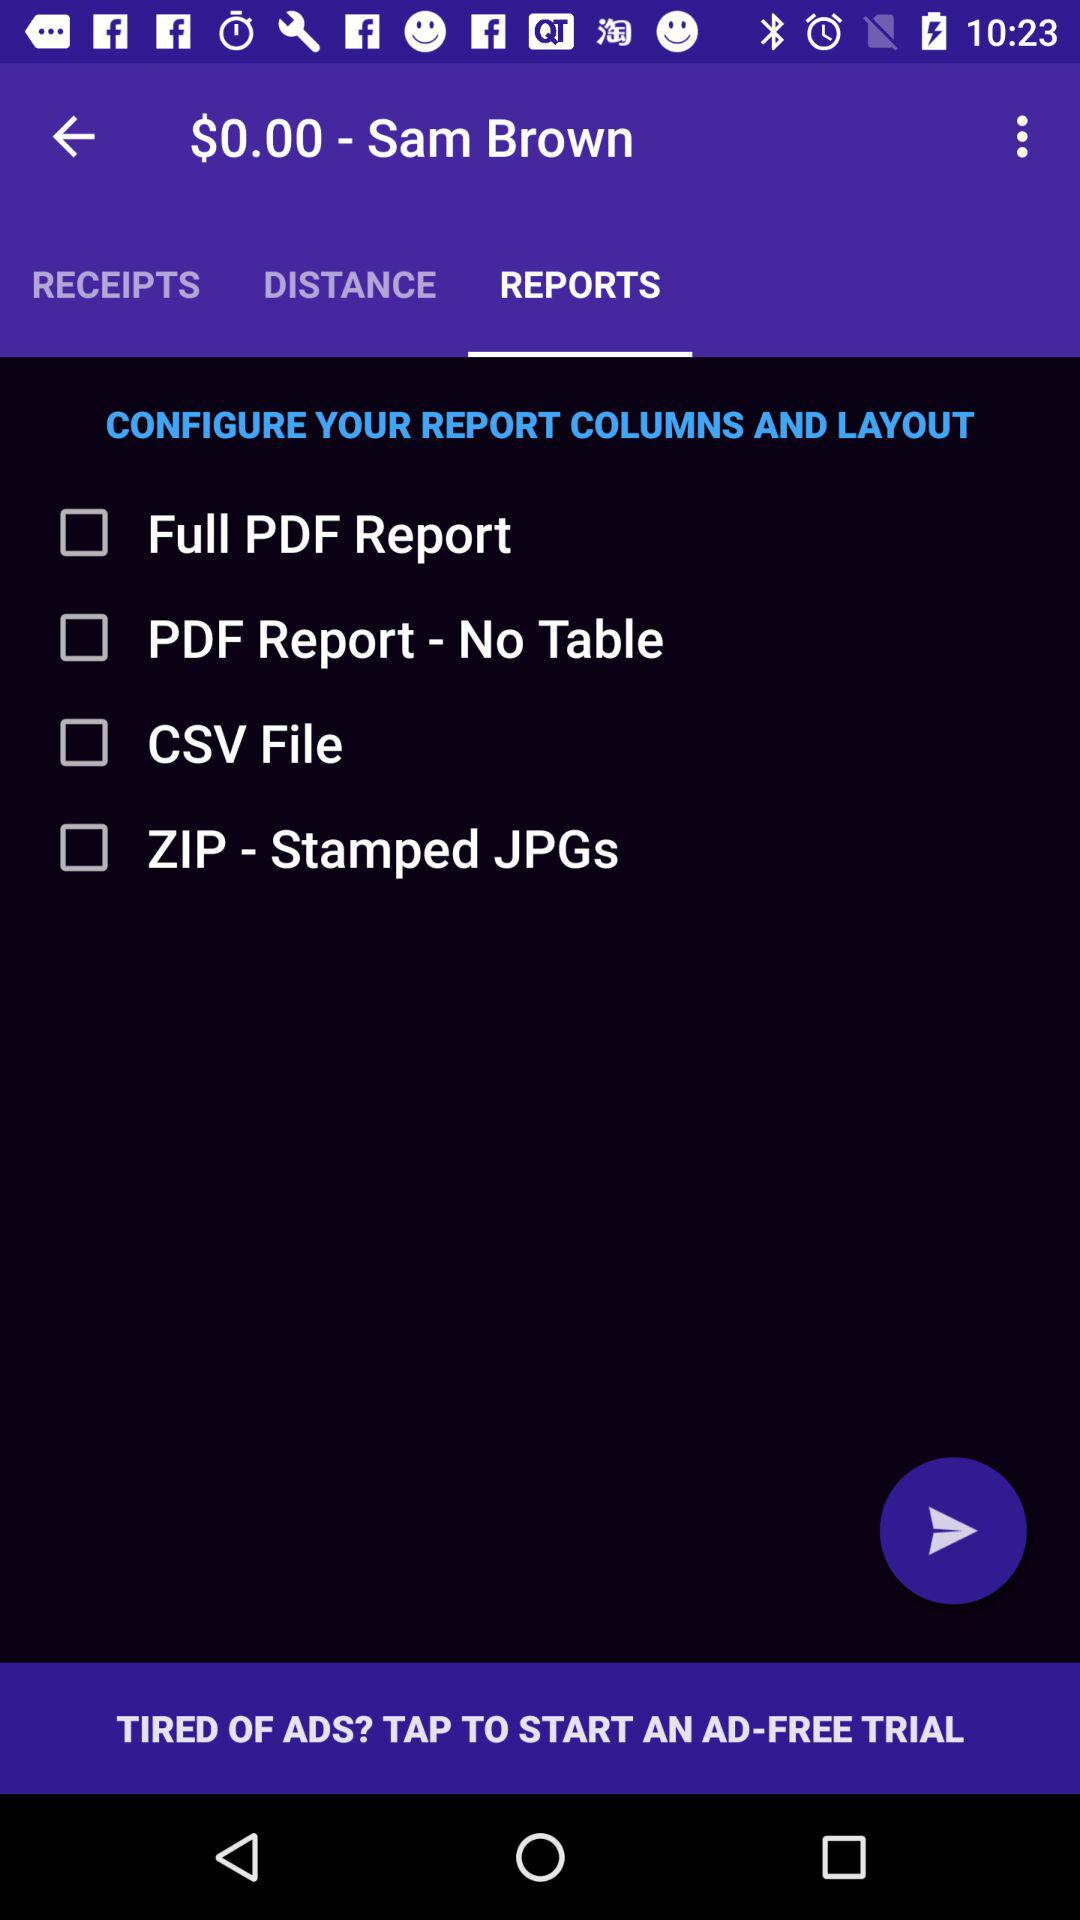Which tab is selected? The selected tab is "REPORTS". 